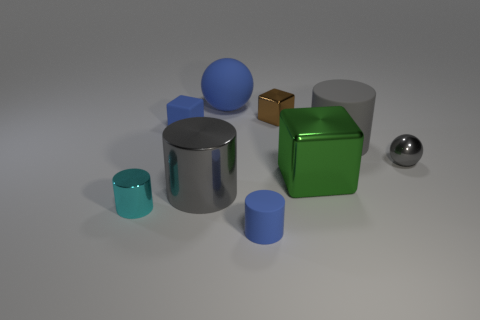Can you tell me the material and color of the large cylindrical object? The large cylindrical object has a silver color and a metallic texture, reminiscent of stainless steel or polished chrome. 